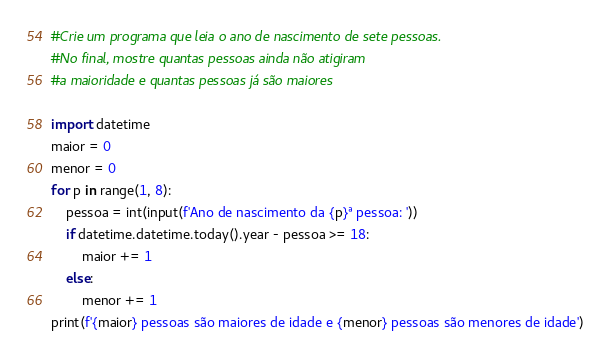<code> <loc_0><loc_0><loc_500><loc_500><_Python_>#Crie um programa que leia o ano de nascimento de sete pessoas.
#No final, mostre quantas pessoas ainda não atigiram
#a maioridade e quantas pessoas já são maiores

import datetime
maior = 0
menor = 0
for p in range(1, 8):
    pessoa = int(input(f'Ano de nascimento da {p}ª pessoa: '))
    if datetime.datetime.today().year - pessoa >= 18:
        maior += 1
    else:
        menor += 1
print(f'{maior} pessoas são maiores de idade e {menor} pessoas são menores de idade')
</code> 